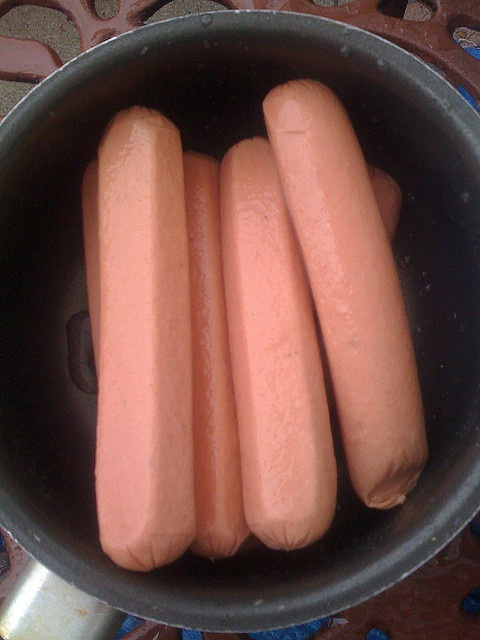Describe the objects in this image and their specific colors. I can see bowl in black, brown, and salmon tones, hot dog in brown and salmon tones, hot dog in brown, salmon, and maroon tones, hot dog in brown and salmon tones, and hot dog in brown, maroon, and salmon tones in this image. 